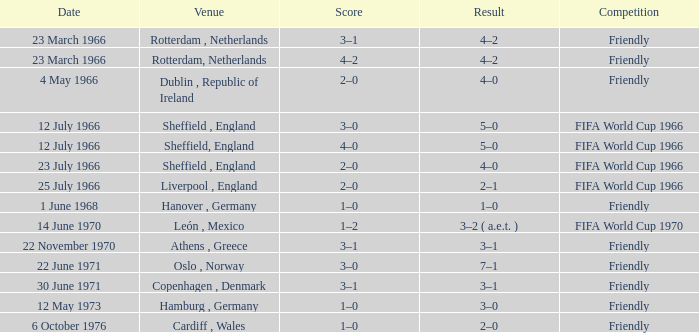Which result's venue was in Rotterdam, Netherlands? 4–2, 4–2. 